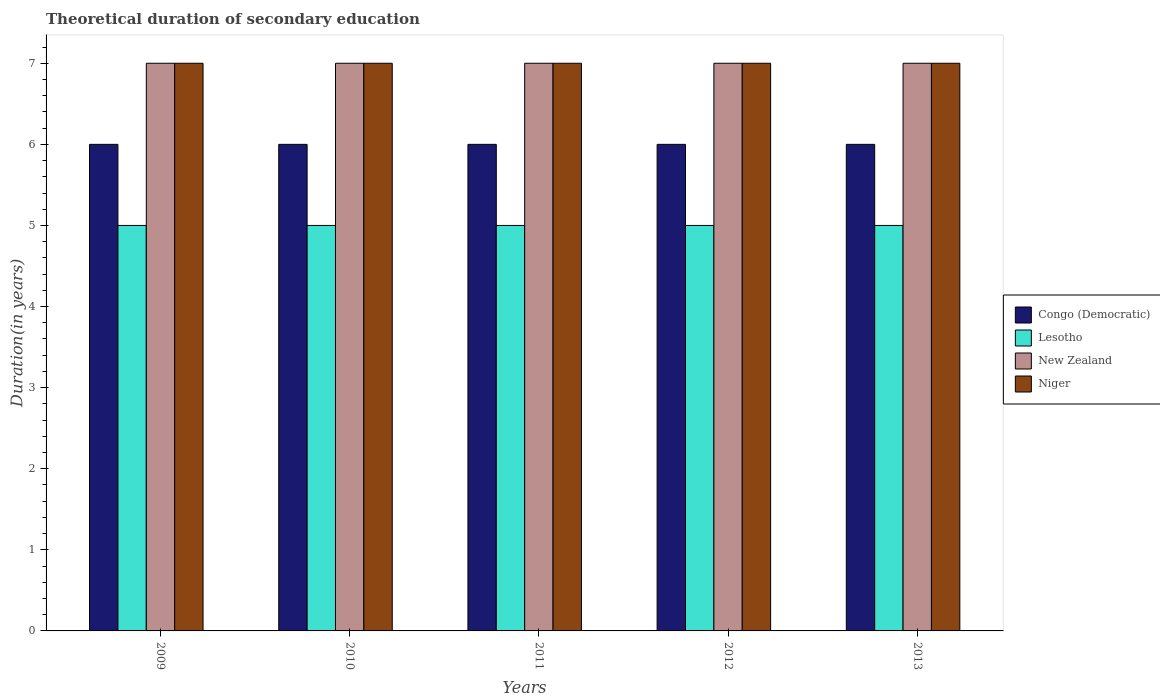How many groups of bars are there?
Make the answer very short. 5. Are the number of bars per tick equal to the number of legend labels?
Provide a short and direct response. Yes. How many bars are there on the 5th tick from the left?
Provide a succinct answer. 4. Across all years, what is the maximum total theoretical duration of secondary education in New Zealand?
Your answer should be very brief. 7. Across all years, what is the minimum total theoretical duration of secondary education in New Zealand?
Give a very brief answer. 7. In which year was the total theoretical duration of secondary education in Congo (Democratic) minimum?
Provide a short and direct response. 2009. What is the total total theoretical duration of secondary education in Niger in the graph?
Provide a succinct answer. 35. What is the difference between the total theoretical duration of secondary education in Lesotho in 2010 and the total theoretical duration of secondary education in New Zealand in 2013?
Your answer should be compact. -2. What is the average total theoretical duration of secondary education in New Zealand per year?
Give a very brief answer. 7. In the year 2009, what is the difference between the total theoretical duration of secondary education in Lesotho and total theoretical duration of secondary education in Congo (Democratic)?
Offer a terse response. -1. In how many years, is the total theoretical duration of secondary education in Niger greater than 0.4 years?
Your answer should be compact. 5. What is the ratio of the total theoretical duration of secondary education in Niger in 2009 to that in 2013?
Make the answer very short. 1. Is the total theoretical duration of secondary education in Niger in 2009 less than that in 2012?
Offer a very short reply. No. In how many years, is the total theoretical duration of secondary education in New Zealand greater than the average total theoretical duration of secondary education in New Zealand taken over all years?
Offer a terse response. 0. Is the sum of the total theoretical duration of secondary education in New Zealand in 2012 and 2013 greater than the maximum total theoretical duration of secondary education in Lesotho across all years?
Give a very brief answer. Yes. Is it the case that in every year, the sum of the total theoretical duration of secondary education in New Zealand and total theoretical duration of secondary education in Niger is greater than the sum of total theoretical duration of secondary education in Lesotho and total theoretical duration of secondary education in Congo (Democratic)?
Your response must be concise. Yes. What does the 3rd bar from the left in 2012 represents?
Your answer should be very brief. New Zealand. What does the 3rd bar from the right in 2009 represents?
Offer a terse response. Lesotho. How many bars are there?
Provide a succinct answer. 20. What is the difference between two consecutive major ticks on the Y-axis?
Your answer should be very brief. 1. Does the graph contain any zero values?
Make the answer very short. No. Does the graph contain grids?
Give a very brief answer. No. What is the title of the graph?
Give a very brief answer. Theoretical duration of secondary education. What is the label or title of the X-axis?
Your response must be concise. Years. What is the label or title of the Y-axis?
Your answer should be very brief. Duration(in years). What is the Duration(in years) of Congo (Democratic) in 2009?
Offer a terse response. 6. What is the Duration(in years) of Lesotho in 2009?
Your answer should be compact. 5. What is the Duration(in years) in New Zealand in 2010?
Offer a very short reply. 7. What is the Duration(in years) of Congo (Democratic) in 2012?
Provide a short and direct response. 6. What is the Duration(in years) of Lesotho in 2013?
Ensure brevity in your answer.  5. What is the Duration(in years) of New Zealand in 2013?
Provide a succinct answer. 7. What is the Duration(in years) in Niger in 2013?
Your answer should be very brief. 7. Across all years, what is the maximum Duration(in years) in Congo (Democratic)?
Provide a short and direct response. 6. Across all years, what is the maximum Duration(in years) of Niger?
Provide a succinct answer. 7. Across all years, what is the minimum Duration(in years) of Congo (Democratic)?
Your response must be concise. 6. What is the total Duration(in years) of Congo (Democratic) in the graph?
Give a very brief answer. 30. What is the total Duration(in years) of Lesotho in the graph?
Provide a short and direct response. 25. What is the total Duration(in years) in New Zealand in the graph?
Keep it short and to the point. 35. What is the total Duration(in years) in Niger in the graph?
Your response must be concise. 35. What is the difference between the Duration(in years) of Lesotho in 2009 and that in 2010?
Offer a very short reply. 0. What is the difference between the Duration(in years) in New Zealand in 2009 and that in 2010?
Ensure brevity in your answer.  0. What is the difference between the Duration(in years) of Congo (Democratic) in 2009 and that in 2012?
Provide a short and direct response. 0. What is the difference between the Duration(in years) in Niger in 2009 and that in 2012?
Your answer should be very brief. 0. What is the difference between the Duration(in years) in Lesotho in 2009 and that in 2013?
Your answer should be very brief. 0. What is the difference between the Duration(in years) of New Zealand in 2009 and that in 2013?
Give a very brief answer. 0. What is the difference between the Duration(in years) in Congo (Democratic) in 2010 and that in 2011?
Offer a terse response. 0. What is the difference between the Duration(in years) of Lesotho in 2010 and that in 2011?
Give a very brief answer. 0. What is the difference between the Duration(in years) of New Zealand in 2010 and that in 2011?
Offer a terse response. 0. What is the difference between the Duration(in years) of New Zealand in 2010 and that in 2012?
Provide a succinct answer. 0. What is the difference between the Duration(in years) of Congo (Democratic) in 2010 and that in 2013?
Provide a succinct answer. 0. What is the difference between the Duration(in years) of Lesotho in 2010 and that in 2013?
Your response must be concise. 0. What is the difference between the Duration(in years) of New Zealand in 2010 and that in 2013?
Ensure brevity in your answer.  0. What is the difference between the Duration(in years) in Congo (Democratic) in 2011 and that in 2012?
Ensure brevity in your answer.  0. What is the difference between the Duration(in years) in Lesotho in 2011 and that in 2012?
Give a very brief answer. 0. What is the difference between the Duration(in years) of Congo (Democratic) in 2011 and that in 2013?
Provide a short and direct response. 0. What is the difference between the Duration(in years) of Lesotho in 2011 and that in 2013?
Offer a very short reply. 0. What is the difference between the Duration(in years) of Niger in 2011 and that in 2013?
Make the answer very short. 0. What is the difference between the Duration(in years) of New Zealand in 2012 and that in 2013?
Give a very brief answer. 0. What is the difference between the Duration(in years) in Congo (Democratic) in 2009 and the Duration(in years) in Lesotho in 2010?
Your answer should be compact. 1. What is the difference between the Duration(in years) of Congo (Democratic) in 2009 and the Duration(in years) of New Zealand in 2010?
Offer a terse response. -1. What is the difference between the Duration(in years) in Congo (Democratic) in 2009 and the Duration(in years) in Niger in 2010?
Provide a short and direct response. -1. What is the difference between the Duration(in years) of New Zealand in 2009 and the Duration(in years) of Niger in 2010?
Your response must be concise. 0. What is the difference between the Duration(in years) in Congo (Democratic) in 2009 and the Duration(in years) in Niger in 2011?
Keep it short and to the point. -1. What is the difference between the Duration(in years) in Congo (Democratic) in 2009 and the Duration(in years) in Niger in 2012?
Your response must be concise. -1. What is the difference between the Duration(in years) of Lesotho in 2009 and the Duration(in years) of Niger in 2012?
Ensure brevity in your answer.  -2. What is the difference between the Duration(in years) of New Zealand in 2009 and the Duration(in years) of Niger in 2012?
Provide a succinct answer. 0. What is the difference between the Duration(in years) in Congo (Democratic) in 2010 and the Duration(in years) in Niger in 2011?
Offer a terse response. -1. What is the difference between the Duration(in years) of New Zealand in 2010 and the Duration(in years) of Niger in 2011?
Keep it short and to the point. 0. What is the difference between the Duration(in years) in Congo (Democratic) in 2010 and the Duration(in years) in Lesotho in 2012?
Provide a succinct answer. 1. What is the difference between the Duration(in years) of Congo (Democratic) in 2010 and the Duration(in years) of Niger in 2012?
Make the answer very short. -1. What is the difference between the Duration(in years) in Lesotho in 2010 and the Duration(in years) in Niger in 2012?
Provide a succinct answer. -2. What is the difference between the Duration(in years) of New Zealand in 2010 and the Duration(in years) of Niger in 2012?
Your answer should be very brief. 0. What is the difference between the Duration(in years) of Congo (Democratic) in 2010 and the Duration(in years) of Lesotho in 2013?
Provide a short and direct response. 1. What is the difference between the Duration(in years) in Congo (Democratic) in 2010 and the Duration(in years) in New Zealand in 2013?
Ensure brevity in your answer.  -1. What is the difference between the Duration(in years) in Lesotho in 2010 and the Duration(in years) in New Zealand in 2013?
Provide a short and direct response. -2. What is the difference between the Duration(in years) in Lesotho in 2010 and the Duration(in years) in Niger in 2013?
Provide a short and direct response. -2. What is the difference between the Duration(in years) in New Zealand in 2010 and the Duration(in years) in Niger in 2013?
Your answer should be compact. 0. What is the difference between the Duration(in years) of Congo (Democratic) in 2011 and the Duration(in years) of Lesotho in 2012?
Offer a terse response. 1. What is the difference between the Duration(in years) of Lesotho in 2011 and the Duration(in years) of New Zealand in 2012?
Your answer should be very brief. -2. What is the difference between the Duration(in years) in Lesotho in 2011 and the Duration(in years) in Niger in 2012?
Ensure brevity in your answer.  -2. What is the difference between the Duration(in years) of Congo (Democratic) in 2011 and the Duration(in years) of Lesotho in 2013?
Your answer should be very brief. 1. What is the difference between the Duration(in years) of Congo (Democratic) in 2011 and the Duration(in years) of New Zealand in 2013?
Your answer should be compact. -1. What is the difference between the Duration(in years) of Congo (Democratic) in 2012 and the Duration(in years) of Lesotho in 2013?
Your response must be concise. 1. What is the difference between the Duration(in years) in Congo (Democratic) in 2012 and the Duration(in years) in Niger in 2013?
Make the answer very short. -1. What is the difference between the Duration(in years) of Lesotho in 2012 and the Duration(in years) of Niger in 2013?
Offer a very short reply. -2. What is the average Duration(in years) of Lesotho per year?
Ensure brevity in your answer.  5. What is the average Duration(in years) of Niger per year?
Provide a succinct answer. 7. In the year 2009, what is the difference between the Duration(in years) in Congo (Democratic) and Duration(in years) in Lesotho?
Your answer should be compact. 1. In the year 2009, what is the difference between the Duration(in years) in Congo (Democratic) and Duration(in years) in New Zealand?
Provide a short and direct response. -1. In the year 2009, what is the difference between the Duration(in years) of Lesotho and Duration(in years) of New Zealand?
Your response must be concise. -2. In the year 2010, what is the difference between the Duration(in years) in Lesotho and Duration(in years) in Niger?
Your answer should be compact. -2. In the year 2010, what is the difference between the Duration(in years) in New Zealand and Duration(in years) in Niger?
Your answer should be compact. 0. In the year 2011, what is the difference between the Duration(in years) of Congo (Democratic) and Duration(in years) of Lesotho?
Ensure brevity in your answer.  1. In the year 2011, what is the difference between the Duration(in years) of Congo (Democratic) and Duration(in years) of New Zealand?
Give a very brief answer. -1. In the year 2011, what is the difference between the Duration(in years) in Lesotho and Duration(in years) in Niger?
Offer a terse response. -2. In the year 2012, what is the difference between the Duration(in years) in Lesotho and Duration(in years) in Niger?
Make the answer very short. -2. In the year 2012, what is the difference between the Duration(in years) in New Zealand and Duration(in years) in Niger?
Your answer should be very brief. 0. In the year 2013, what is the difference between the Duration(in years) in Congo (Democratic) and Duration(in years) in Lesotho?
Give a very brief answer. 1. What is the ratio of the Duration(in years) in Congo (Democratic) in 2009 to that in 2011?
Provide a succinct answer. 1. What is the ratio of the Duration(in years) in Niger in 2009 to that in 2011?
Make the answer very short. 1. What is the ratio of the Duration(in years) in Congo (Democratic) in 2009 to that in 2012?
Make the answer very short. 1. What is the ratio of the Duration(in years) of New Zealand in 2009 to that in 2012?
Make the answer very short. 1. What is the ratio of the Duration(in years) of Niger in 2009 to that in 2012?
Your answer should be very brief. 1. What is the ratio of the Duration(in years) in Lesotho in 2010 to that in 2011?
Provide a succinct answer. 1. What is the ratio of the Duration(in years) of New Zealand in 2010 to that in 2011?
Your answer should be very brief. 1. What is the ratio of the Duration(in years) in Niger in 2010 to that in 2011?
Your response must be concise. 1. What is the ratio of the Duration(in years) in Lesotho in 2010 to that in 2012?
Give a very brief answer. 1. What is the ratio of the Duration(in years) in New Zealand in 2010 to that in 2012?
Your response must be concise. 1. What is the ratio of the Duration(in years) of Niger in 2010 to that in 2012?
Your answer should be compact. 1. What is the ratio of the Duration(in years) of Congo (Democratic) in 2010 to that in 2013?
Ensure brevity in your answer.  1. What is the ratio of the Duration(in years) of New Zealand in 2010 to that in 2013?
Your response must be concise. 1. What is the ratio of the Duration(in years) in Congo (Democratic) in 2011 to that in 2012?
Provide a short and direct response. 1. What is the ratio of the Duration(in years) in Lesotho in 2011 to that in 2012?
Ensure brevity in your answer.  1. What is the ratio of the Duration(in years) of Congo (Democratic) in 2011 to that in 2013?
Offer a very short reply. 1. What is the ratio of the Duration(in years) in New Zealand in 2011 to that in 2013?
Your answer should be compact. 1. What is the ratio of the Duration(in years) of Niger in 2011 to that in 2013?
Provide a short and direct response. 1. What is the ratio of the Duration(in years) in Congo (Democratic) in 2012 to that in 2013?
Provide a short and direct response. 1. What is the ratio of the Duration(in years) of New Zealand in 2012 to that in 2013?
Your answer should be compact. 1. What is the difference between the highest and the second highest Duration(in years) in Congo (Democratic)?
Provide a succinct answer. 0. What is the difference between the highest and the second highest Duration(in years) in Niger?
Ensure brevity in your answer.  0. What is the difference between the highest and the lowest Duration(in years) of Congo (Democratic)?
Your answer should be very brief. 0. What is the difference between the highest and the lowest Duration(in years) of Lesotho?
Give a very brief answer. 0. What is the difference between the highest and the lowest Duration(in years) of New Zealand?
Make the answer very short. 0. What is the difference between the highest and the lowest Duration(in years) in Niger?
Provide a succinct answer. 0. 